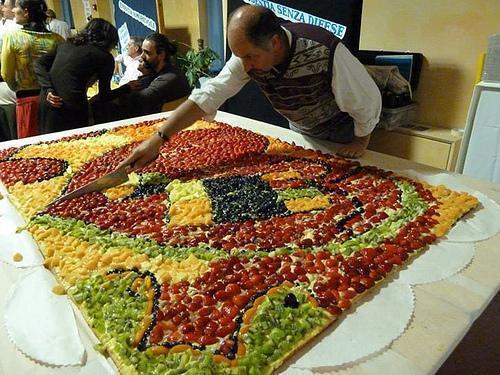How many knives are shown?
Give a very brief answer. 1. 